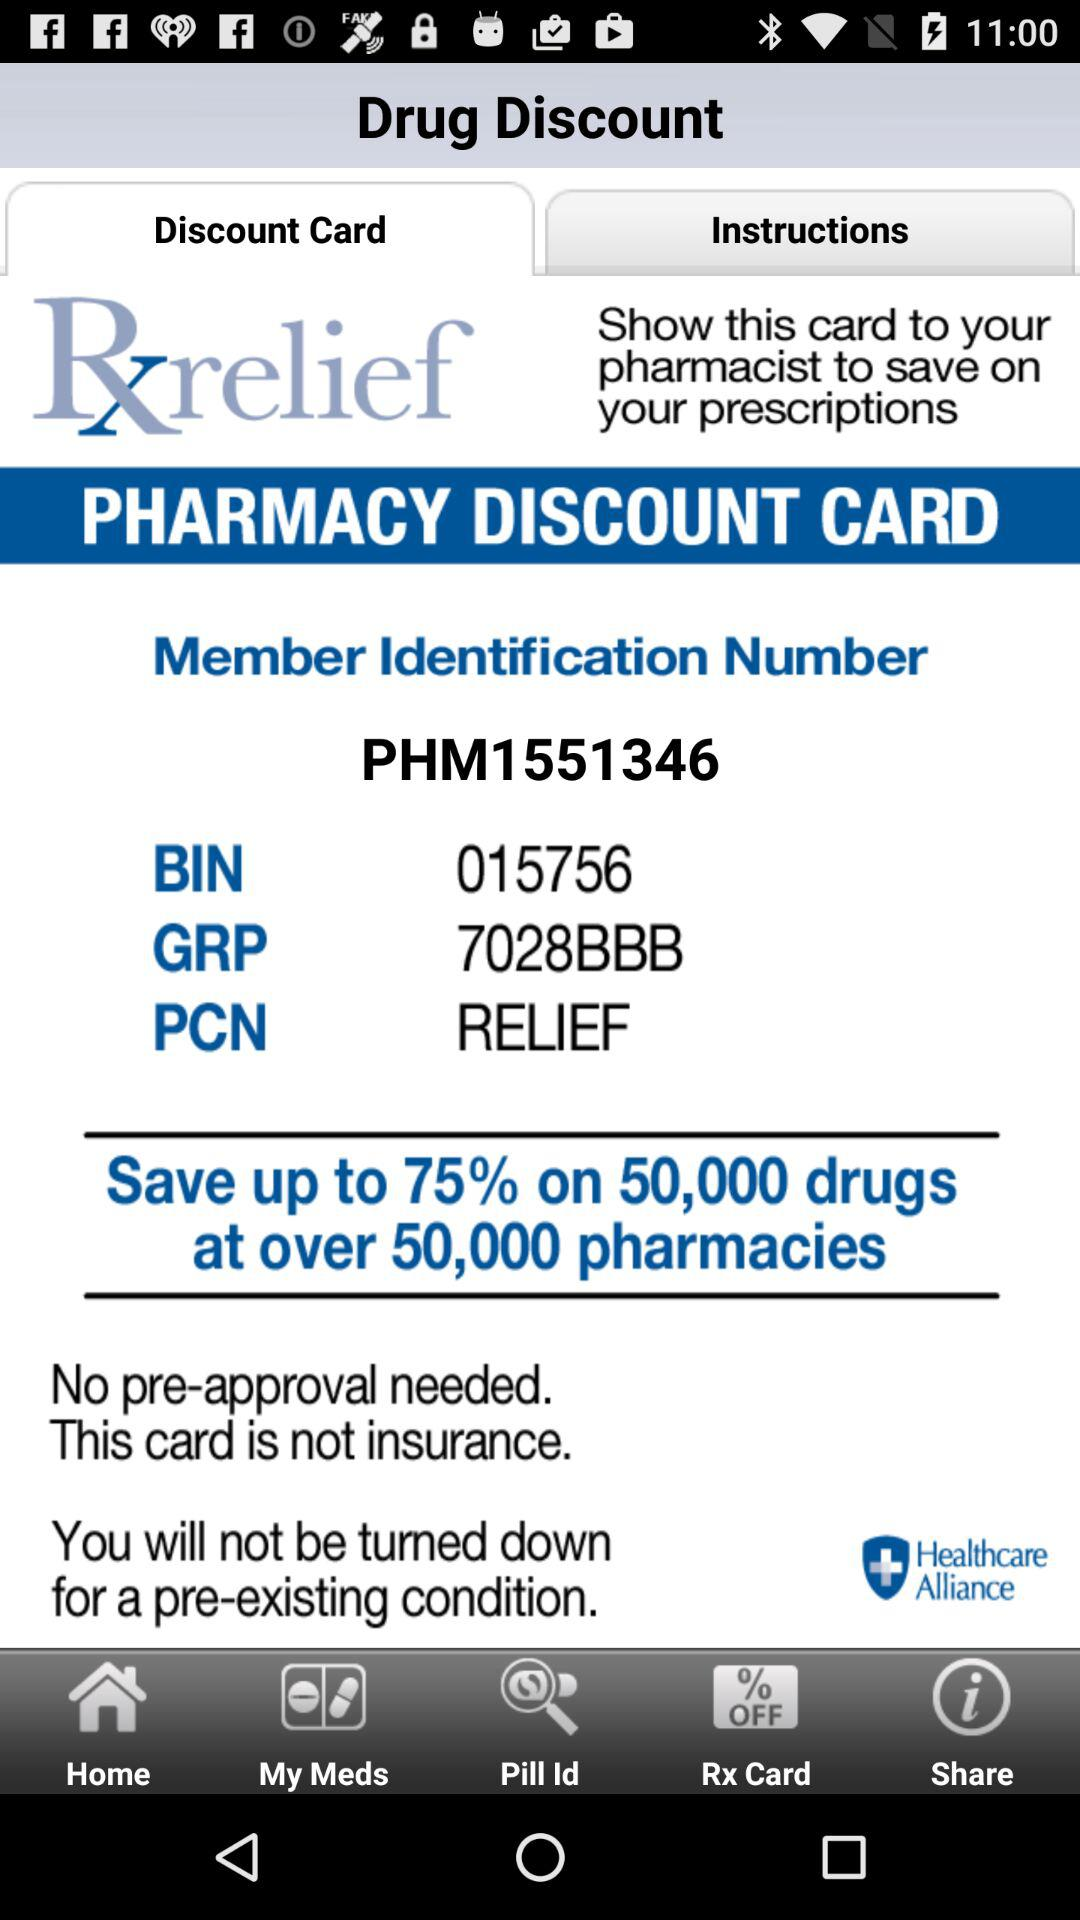How much of a percentage can we save on 50,000 drugs? You can save up to 75%. 